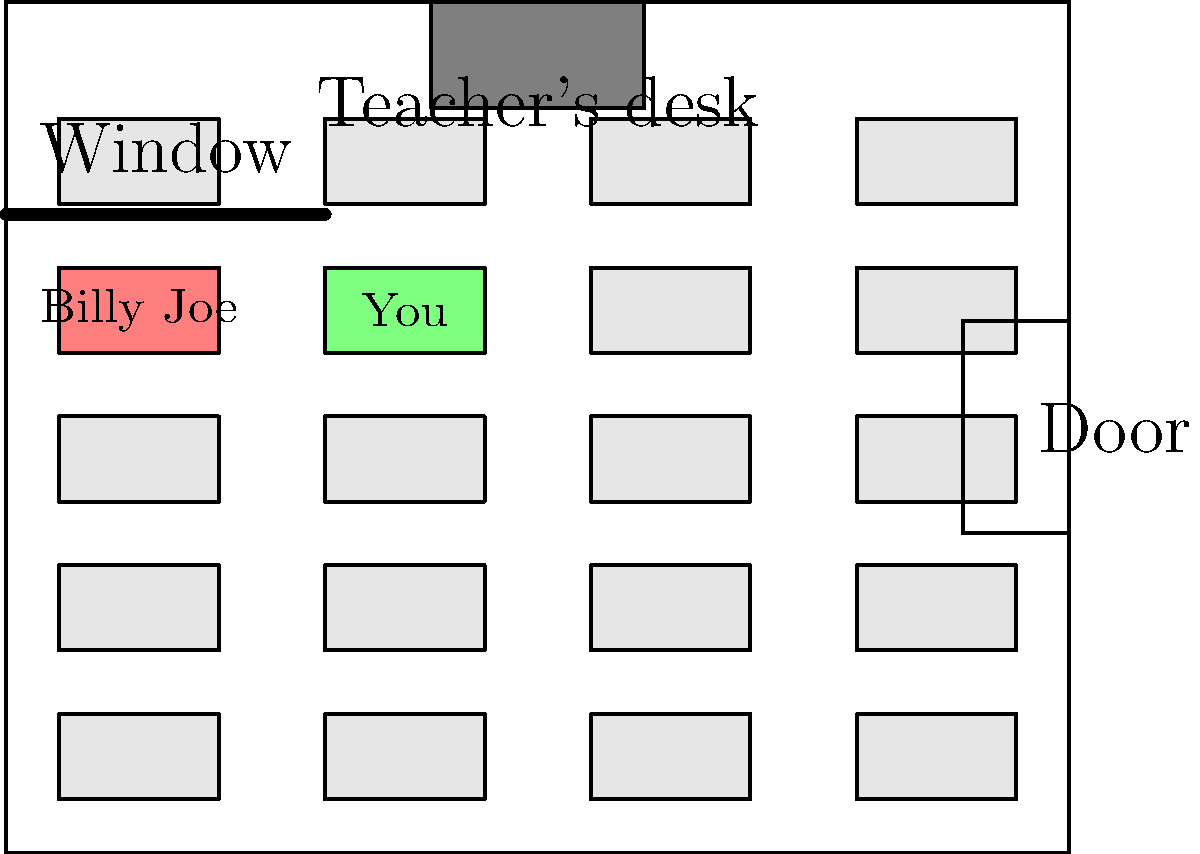In our elementary school classroom, how many students were sitting between you and Billy Joe Taylor in the same row? To determine how many students were sitting between you and Billy Joe Taylor, let's follow these steps:

1. Locate Billy Joe Taylor's desk in the classroom layout. It's the pink-colored desk on the left side of the third row from the bottom.

2. Find your desk in the same row. It's the green-colored desk, two desks to the right of Billy Joe's desk.

3. Count the number of desks between your desk and Billy Joe's desk in the same row. We can see that there is one desk between you and Billy Joe.

4. Each desk represents one student, so the number of students sitting between you and Billy Joe is equal to the number of desks between you.

Therefore, there was one student sitting between you and Billy Joe Taylor in the same row of your elementary school classroom.
Answer: 1 student 